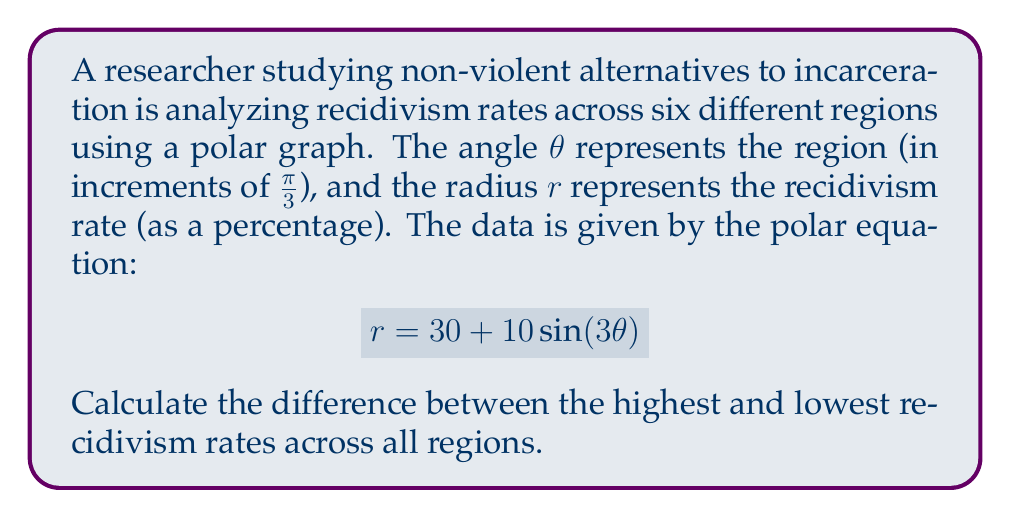What is the answer to this math problem? To solve this problem, we need to follow these steps:

1) The function $r = 30 + 10\sin(3\theta)$ repeats every $\frac{2\pi}{3}$ radians. Since we're considering six regions over $2\pi$ radians, we'll capture all unique values.

2) To find the maximum and minimum values, we need to find where $\frac{d}{d\theta}r = 0$:

   $$\frac{d}{d\theta}r = 30\cos(3\theta)$$

   This equals zero when $3\theta = \frac{\pi}{2}$ or $\frac{3\pi}{2}$, i.e., when $\theta = \frac{\pi}{6}$ or $\frac{\pi}{2}$.

3) Evaluating $r$ at these points:

   At $\theta = \frac{\pi}{6}$: $r = 30 + 10\sin(\frac{\pi}{2}) = 30 + 10 = 40$
   At $\theta = \frac{\pi}{2}$: $r = 30 + 10\sin(\frac{3\pi}{2}) = 30 - 10 = 20$

4) The maximum recidivism rate is 40% and the minimum is 20%.

5) The difference between the highest and lowest rates is 40% - 20% = 20%.
Answer: The difference between the highest and lowest recidivism rates is 20%. 